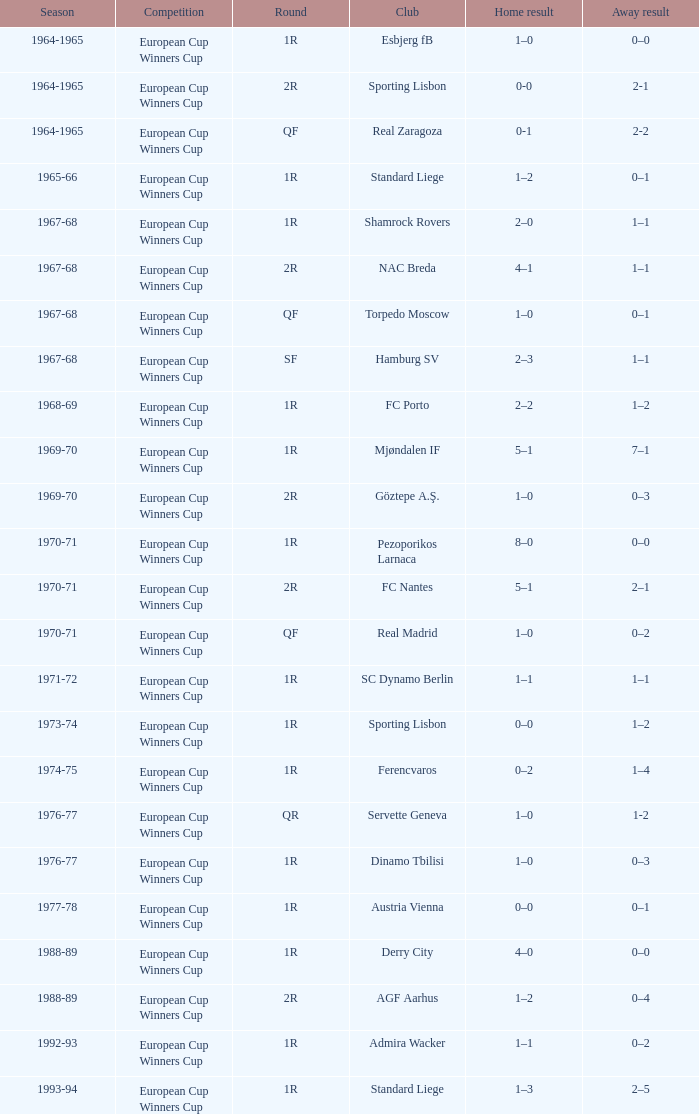What event had a 0-3 away score during the 1969-70 season? European Cup Winners Cup. 